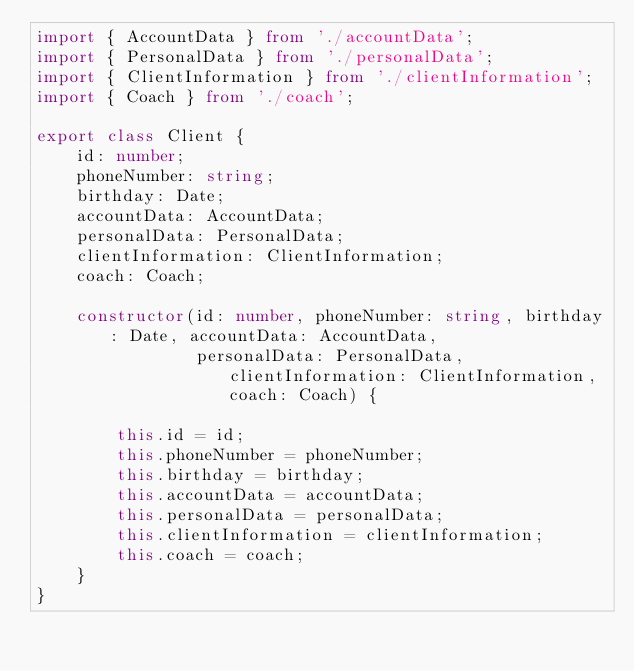<code> <loc_0><loc_0><loc_500><loc_500><_TypeScript_>import { AccountData } from './accountData';
import { PersonalData } from './personalData';
import { ClientInformation } from './clientInformation';
import { Coach } from './coach';

export class Client {
    id: number;
    phoneNumber: string;
    birthday: Date;
    accountData: AccountData;
    personalData: PersonalData;
    clientInformation: ClientInformation;
    coach: Coach;

    constructor(id: number, phoneNumber: string, birthday: Date, accountData: AccountData,
                personalData: PersonalData, clientInformation: ClientInformation, coach: Coach) {

        this.id = id;
        this.phoneNumber = phoneNumber;
        this.birthday = birthday;
        this.accountData = accountData;
        this.personalData = personalData;
        this.clientInformation = clientInformation;
        this.coach = coach;
    }
}
</code> 